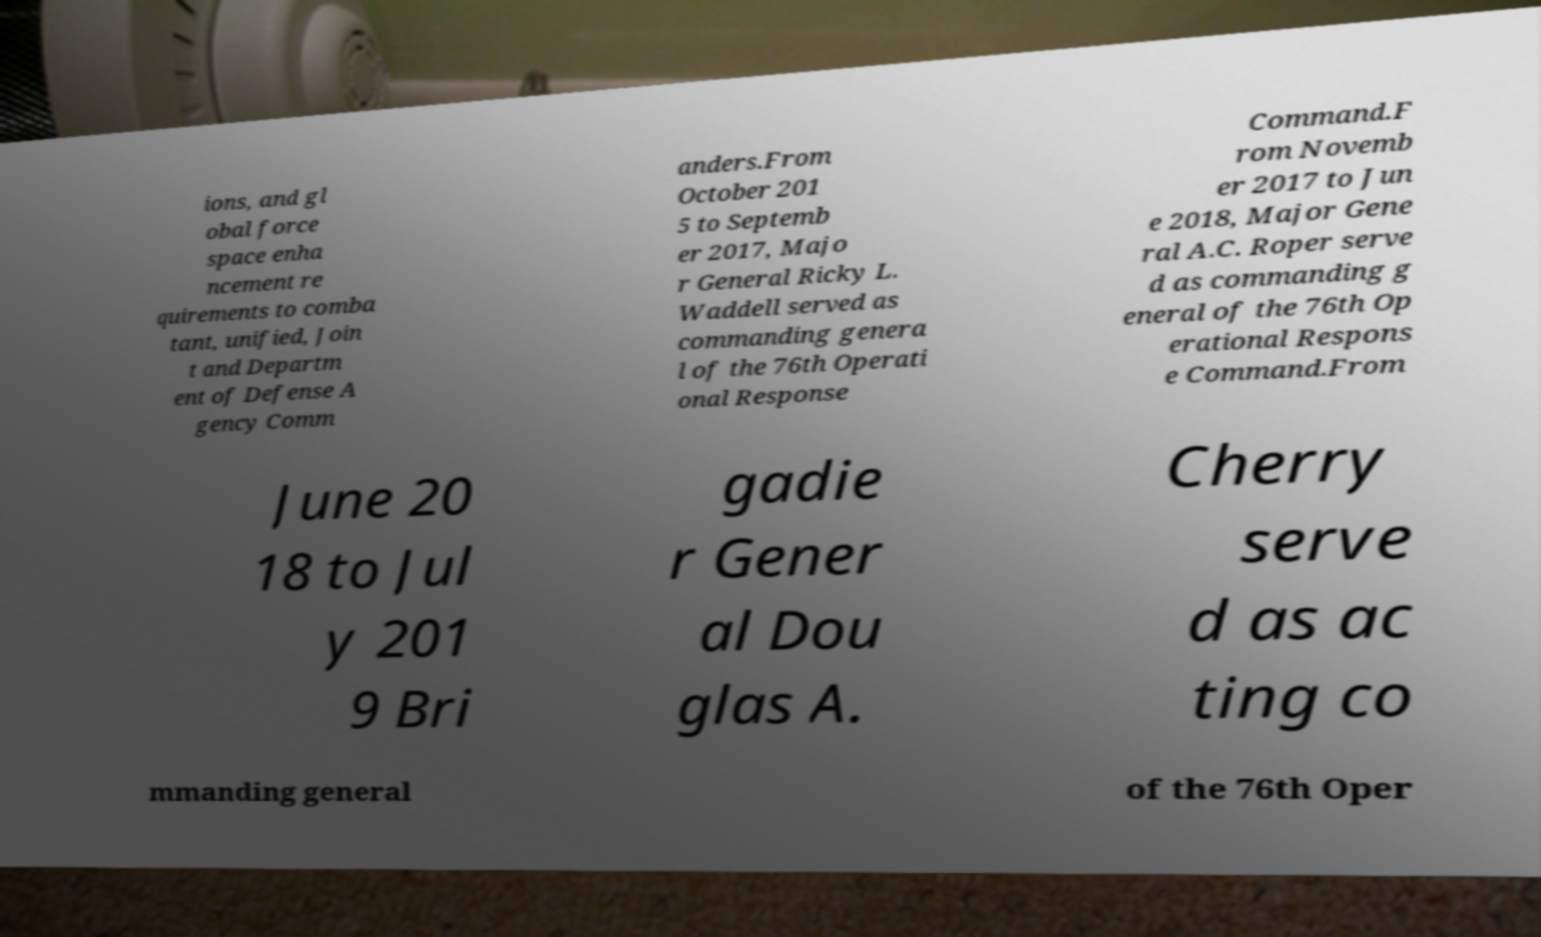Please identify and transcribe the text found in this image. ions, and gl obal force space enha ncement re quirements to comba tant, unified, Join t and Departm ent of Defense A gency Comm anders.From October 201 5 to Septemb er 2017, Majo r General Ricky L. Waddell served as commanding genera l of the 76th Operati onal Response Command.F rom Novemb er 2017 to Jun e 2018, Major Gene ral A.C. Roper serve d as commanding g eneral of the 76th Op erational Respons e Command.From June 20 18 to Jul y 201 9 Bri gadie r Gener al Dou glas A. Cherry serve d as ac ting co mmanding general of the 76th Oper 